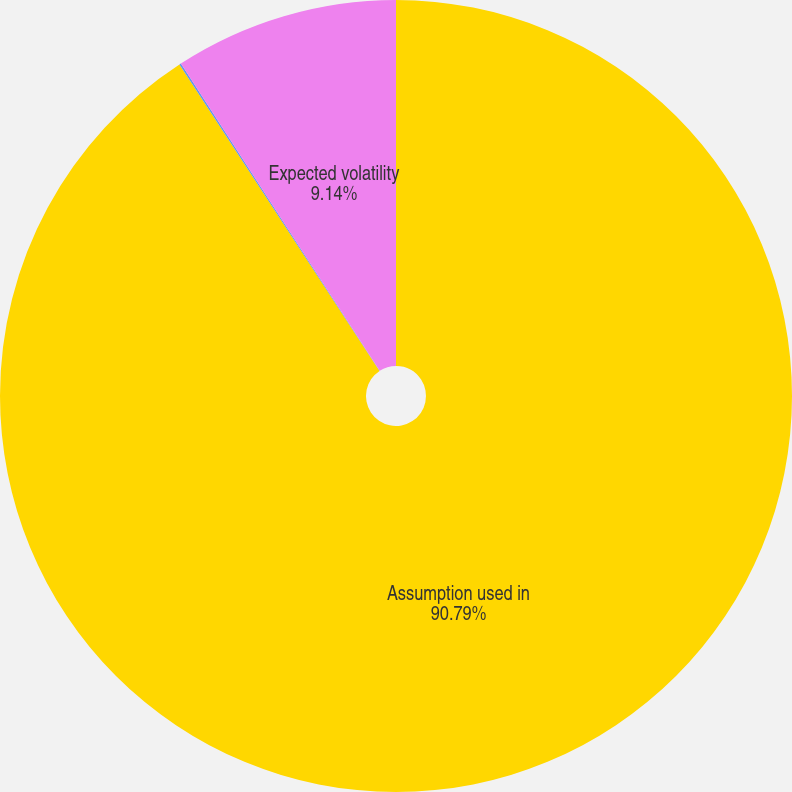Convert chart. <chart><loc_0><loc_0><loc_500><loc_500><pie_chart><fcel>Assumption used in<fcel>Expected dividend yield<fcel>Expected volatility<nl><fcel>90.8%<fcel>0.07%<fcel>9.14%<nl></chart> 